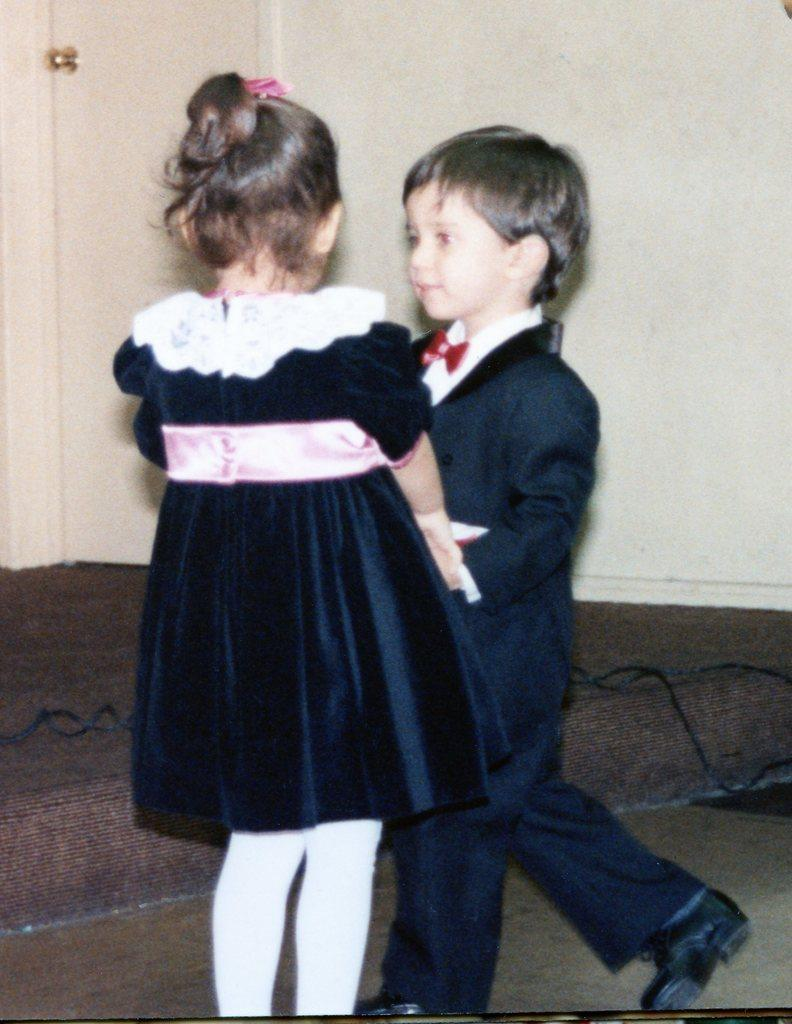How many people are in the image? There are two people in the image, a boy and a girl. What are the boy and girl doing in the image? The boy and girl are standing and holding hands. What can be seen in the background of the image? There is a wall, a door, and wires in the background of the image. What type of oatmeal is being cooked on the stove in the image? There is no stove or oatmeal present in the image. Can you describe the oil that is dripping from the insect in the image? There is no insect or oil present in the image. 